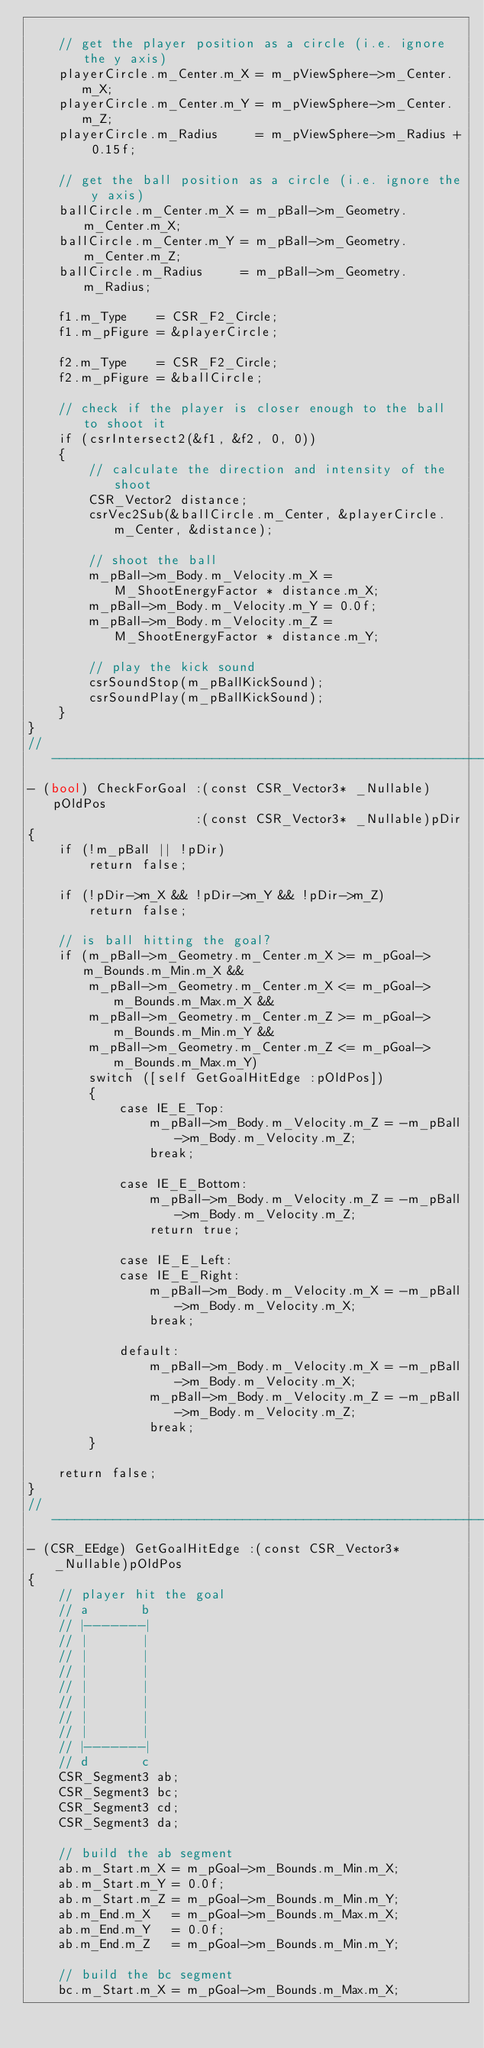<code> <loc_0><loc_0><loc_500><loc_500><_ObjectiveC_>    
    // get the player position as a circle (i.e. ignore the y axis)
    playerCircle.m_Center.m_X = m_pViewSphere->m_Center.m_X;
    playerCircle.m_Center.m_Y = m_pViewSphere->m_Center.m_Z;
    playerCircle.m_Radius     = m_pViewSphere->m_Radius + 0.15f;
    
    // get the ball position as a circle (i.e. ignore the y axis)
    ballCircle.m_Center.m_X = m_pBall->m_Geometry.m_Center.m_X;
    ballCircle.m_Center.m_Y = m_pBall->m_Geometry.m_Center.m_Z;
    ballCircle.m_Radius     = m_pBall->m_Geometry.m_Radius;
    
    f1.m_Type    = CSR_F2_Circle;
    f1.m_pFigure = &playerCircle;
    
    f2.m_Type    = CSR_F2_Circle;
    f2.m_pFigure = &ballCircle;
    
    // check if the player is closer enough to the ball to shoot it
    if (csrIntersect2(&f1, &f2, 0, 0))
    {
        // calculate the direction and intensity of the shoot
        CSR_Vector2 distance;
        csrVec2Sub(&ballCircle.m_Center, &playerCircle.m_Center, &distance);
        
        // shoot the ball
        m_pBall->m_Body.m_Velocity.m_X = M_ShootEnergyFactor * distance.m_X;
        m_pBall->m_Body.m_Velocity.m_Y = 0.0f;
        m_pBall->m_Body.m_Velocity.m_Z = M_ShootEnergyFactor * distance.m_Y;

        // play the kick sound
        csrSoundStop(m_pBallKickSound);
        csrSoundPlay(m_pBallKickSound);
    }
}
//---------------------------------------------------------------------------
- (bool) CheckForGoal :(const CSR_Vector3* _Nullable)pOldPos
                      :(const CSR_Vector3* _Nullable)pDir
{
    if (!m_pBall || !pDir)
        return false;
    
    if (!pDir->m_X && !pDir->m_Y && !pDir->m_Z)
        return false;
    
    // is ball hitting the goal?
    if (m_pBall->m_Geometry.m_Center.m_X >= m_pGoal->m_Bounds.m_Min.m_X &&
        m_pBall->m_Geometry.m_Center.m_X <= m_pGoal->m_Bounds.m_Max.m_X &&
        m_pBall->m_Geometry.m_Center.m_Z >= m_pGoal->m_Bounds.m_Min.m_Y &&
        m_pBall->m_Geometry.m_Center.m_Z <= m_pGoal->m_Bounds.m_Max.m_Y)
        switch ([self GetGoalHitEdge :pOldPos])
        {
            case IE_E_Top:
                m_pBall->m_Body.m_Velocity.m_Z = -m_pBall->m_Body.m_Velocity.m_Z;
                break;
                
            case IE_E_Bottom:
                m_pBall->m_Body.m_Velocity.m_Z = -m_pBall->m_Body.m_Velocity.m_Z;
                return true;
                
            case IE_E_Left:
            case IE_E_Right:
                m_pBall->m_Body.m_Velocity.m_X = -m_pBall->m_Body.m_Velocity.m_X;
                break;
                
            default:
                m_pBall->m_Body.m_Velocity.m_X = -m_pBall->m_Body.m_Velocity.m_X;
                m_pBall->m_Body.m_Velocity.m_Z = -m_pBall->m_Body.m_Velocity.m_Z;
                break;
        }
    
    return false;
}
//---------------------------------------------------------------------------
- (CSR_EEdge) GetGoalHitEdge :(const CSR_Vector3* _Nullable)pOldPos
{
    // player hit the goal
    // a       b
    // |-------|
    // |       |
    // |       |
    // |       |
    // |       |
    // |       |
    // |       |
    // |       |
    // |-------|
    // d       c
    CSR_Segment3 ab;
    CSR_Segment3 bc;
    CSR_Segment3 cd;
    CSR_Segment3 da;
    
    // build the ab segment
    ab.m_Start.m_X = m_pGoal->m_Bounds.m_Min.m_X;
    ab.m_Start.m_Y = 0.0f;
    ab.m_Start.m_Z = m_pGoal->m_Bounds.m_Min.m_Y;
    ab.m_End.m_X   = m_pGoal->m_Bounds.m_Max.m_X;
    ab.m_End.m_Y   = 0.0f;
    ab.m_End.m_Z   = m_pGoal->m_Bounds.m_Min.m_Y;
    
    // build the bc segment
    bc.m_Start.m_X = m_pGoal->m_Bounds.m_Max.m_X;</code> 